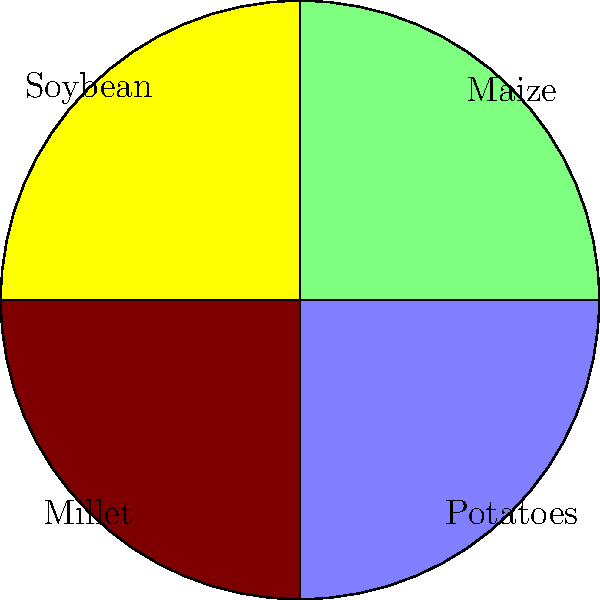In Plateau State, farmers often practice crop rotation to maintain soil fertility. The diagram represents a four-year crop rotation cycle using a cyclic group. If the rotation starts with maize and follows a clockwise direction, what will be the crop planted in the field after 6 rotations? To solve this problem, we need to follow these steps:

1. Identify the cyclic group:
   The group is $C_4$ (cyclic group of order 4), representing the 4-year rotation cycle.

2. Determine the group operation:
   Each complete rotation corresponds to the identity element in the group.

3. Calculate the effect of 6 rotations:
   - 6 rotations = 6 mod 4 = 2 (since 6 ÷ 4 = 1 remainder 2)
   - This means after 6 rotations, we've moved 2 positions clockwise from the starting point.

4. Identify the starting point:
   Maize is the starting crop (at the 12 o'clock position).

5. Move 2 positions clockwise from Maize:
   Maize → Soybean → Millet

Therefore, after 6 rotations, the crop planted will be Millet.
Answer: Millet 